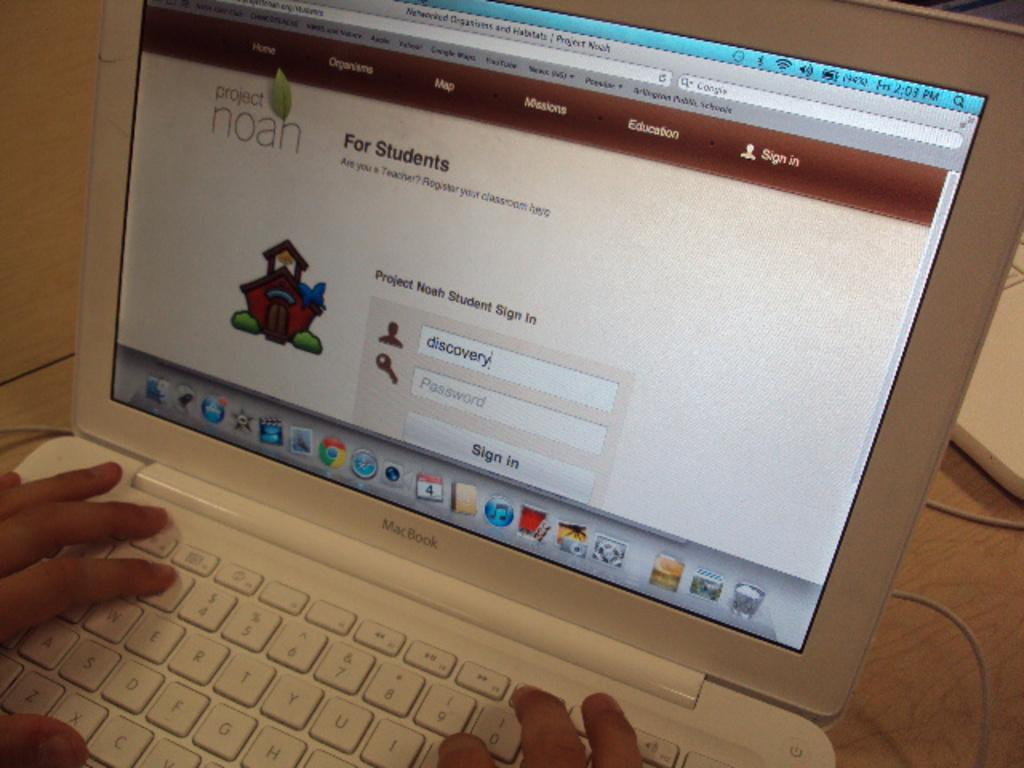<image>
Offer a succinct explanation of the picture presented. A computer screen with a project noah logo on it 